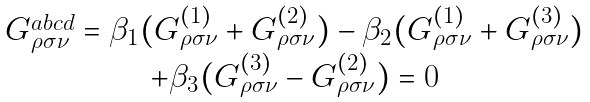<formula> <loc_0><loc_0><loc_500><loc_500>\begin{array} { c } G _ { \rho \sigma \nu } ^ { a b c d } = \beta _ { 1 } ( G _ { \rho \sigma \nu } ^ { ( 1 ) } + G _ { \rho \sigma \nu } ^ { ( 2 ) } ) - \beta _ { 2 } ( G _ { \rho \sigma \nu } ^ { ( 1 ) } + G _ { \rho \sigma \nu } ^ { ( 3 ) } ) \\ + \beta _ { 3 } ( G _ { \rho \sigma \nu } ^ { ( 3 ) } - G _ { \rho \sigma \nu } ^ { ( 2 ) } ) = 0 \end{array}</formula> 